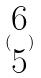Convert formula to latex. <formula><loc_0><loc_0><loc_500><loc_500>( \begin{matrix} 6 \\ 5 \end{matrix} )</formula> 